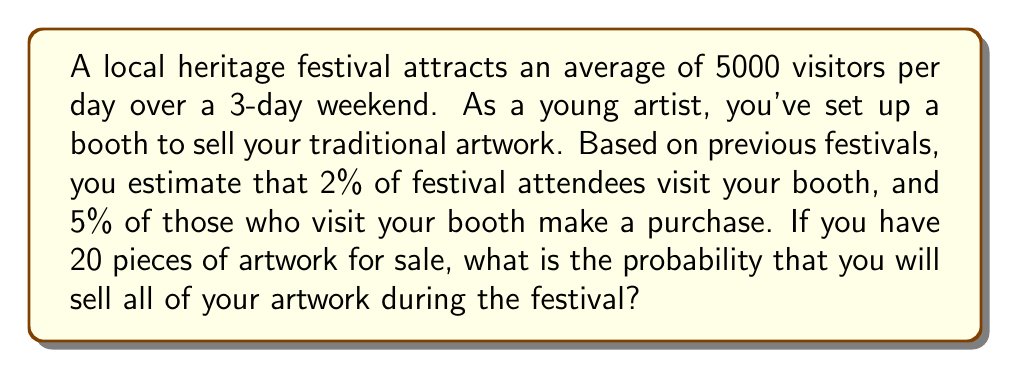What is the answer to this math problem? Let's break this down step-by-step:

1) First, calculate the total number of festival attendees:
   $$ \text{Total attendees} = 5000 \text{ visitors/day} \times 3 \text{ days} = 15000 \text{ visitors} $$

2) Calculate the number of visitors to your booth:
   $$ \text{Booth visitors} = 15000 \times 0.02 = 300 \text{ visitors} $$

3) Calculate the expected number of purchases:
   $$ \text{Expected purchases} = 300 \times 0.05 = 15 \text{ purchases} $$

4) To sell all 20 pieces, we need at least 20 purchases. This follows a binomial distribution with $n=300$ (number of booth visitors) and $p=0.05$ (probability of purchase per visitor).

5) The probability of selling at least 20 pieces is:
   $$ P(X \geq 20) = 1 - P(X < 20) $$
   where $X$ is the number of purchases.

6) Using the cumulative binomial distribution function:
   $$ P(X \geq 20) = 1 - \sum_{k=0}^{19} \binom{300}{k} (0.05)^k (0.95)^{300-k} $$

7) This calculation is complex, but using a calculator or computer, we get:
   $$ P(X \geq 20) \approx 0.1013 $$

Therefore, the probability of selling all 20 pieces during the festival is approximately 0.1013 or 10.13%.
Answer: 0.1013 